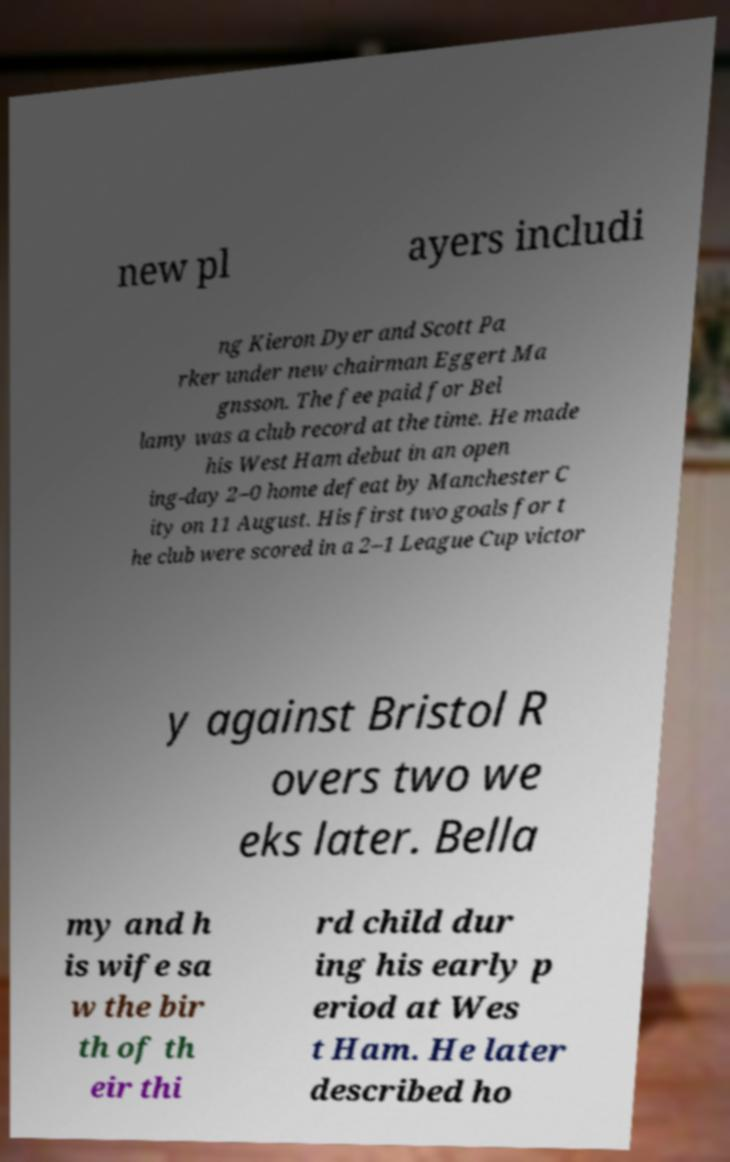Can you accurately transcribe the text from the provided image for me? new pl ayers includi ng Kieron Dyer and Scott Pa rker under new chairman Eggert Ma gnsson. The fee paid for Bel lamy was a club record at the time. He made his West Ham debut in an open ing-day 2–0 home defeat by Manchester C ity on 11 August. His first two goals for t he club were scored in a 2–1 League Cup victor y against Bristol R overs two we eks later. Bella my and h is wife sa w the bir th of th eir thi rd child dur ing his early p eriod at Wes t Ham. He later described ho 